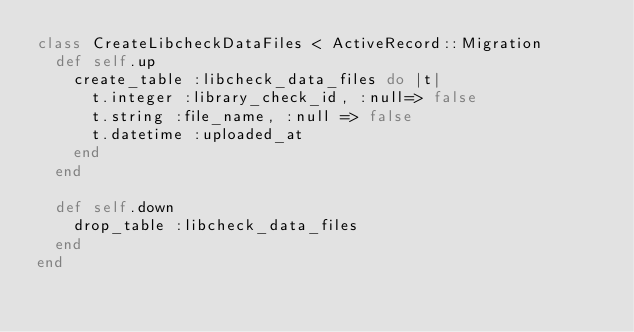<code> <loc_0><loc_0><loc_500><loc_500><_Ruby_>class CreateLibcheckDataFiles < ActiveRecord::Migration
  def self.up
    create_table :libcheck_data_files do |t|
      t.integer :library_check_id, :null=> false
      t.string :file_name, :null => false
      t.datetime :uploaded_at
    end
  end

  def self.down
    drop_table :libcheck_data_files
  end
end
</code> 